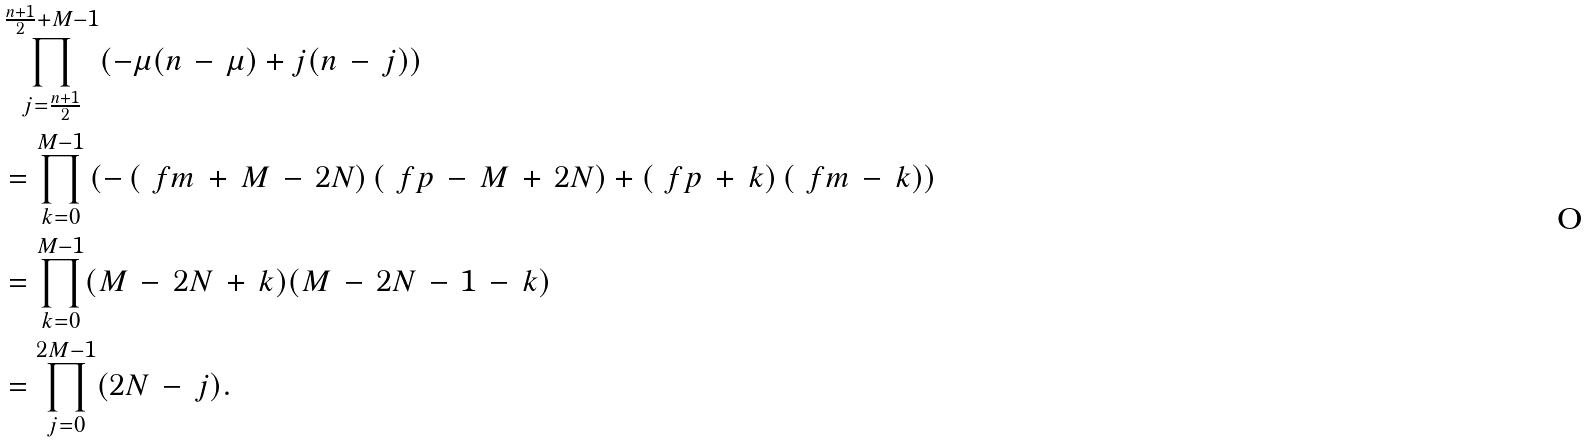Convert formula to latex. <formula><loc_0><loc_0><loc_500><loc_500>& \prod _ { j = \frac { n + 1 } { 2 } } ^ { \frac { n + 1 } { 2 } + M - 1 } ( - \mu ( n \, - \, \mu ) + j ( n \, - \, j ) ) \\ & = \prod _ { k = 0 } ^ { M - 1 } \left ( - \left ( \ f m \, + \, M \, - \, 2 N \right ) \left ( \ f p \, - \, M \, + \, 2 N \right ) + \left ( \ f p \, + \, k \right ) \left ( \ f m \, - \, k \right ) \right ) \\ & = \prod _ { k = 0 } ^ { M - 1 } ( M \, - \, 2 N \, + \, k ) ( M \, - \, 2 N \, - \, 1 \, - \, k ) \\ & = \prod _ { j = 0 } ^ { 2 M - 1 } ( 2 N \, - \, j ) .</formula> 